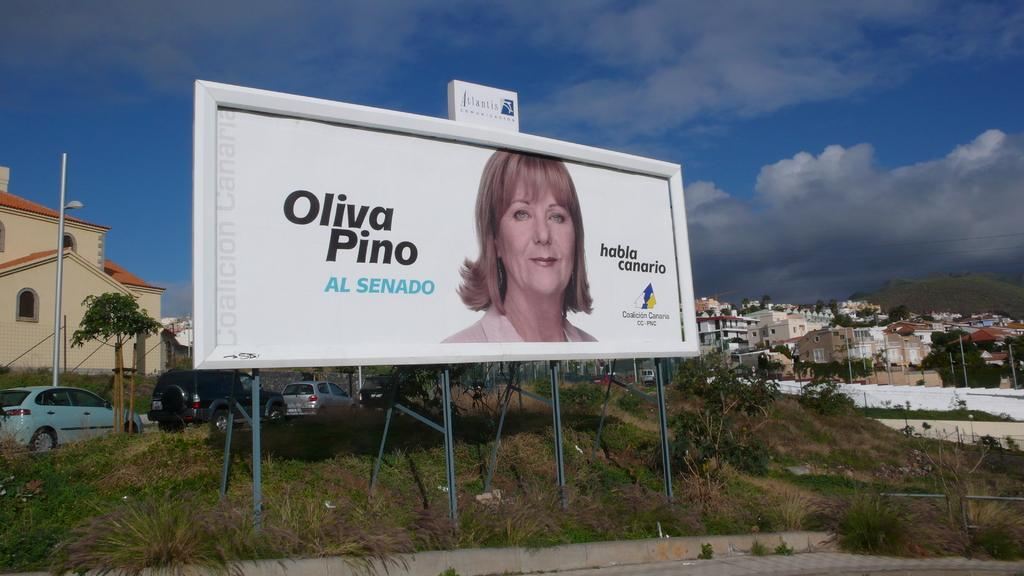<image>
Describe the image concisely. A billboard featuring a picture of a woman with the words Oliva Pino sitting in a run down suburb. 